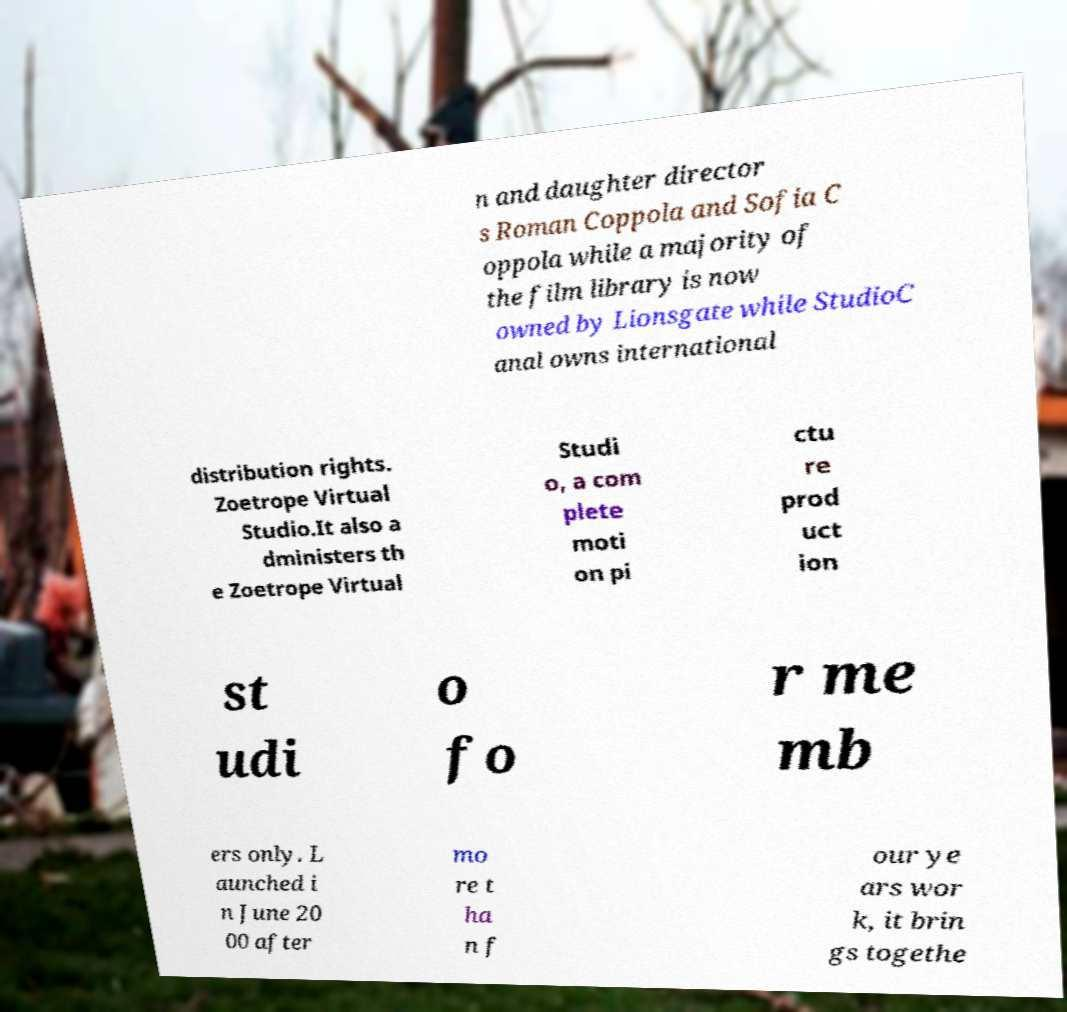Could you extract and type out the text from this image? n and daughter director s Roman Coppola and Sofia C oppola while a majority of the film library is now owned by Lionsgate while StudioC anal owns international distribution rights. Zoetrope Virtual Studio.It also a dministers th e Zoetrope Virtual Studi o, a com plete moti on pi ctu re prod uct ion st udi o fo r me mb ers only. L aunched i n June 20 00 after mo re t ha n f our ye ars wor k, it brin gs togethe 